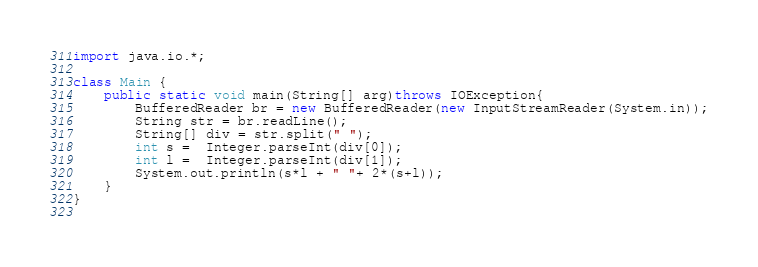<code> <loc_0><loc_0><loc_500><loc_500><_Java_>import java.io.*;

class Main {
    public static void main(String[] arg)throws IOException{
        BufferedReader br = new BufferedReader(new InputStreamReader(System.in));
        String str = br.readLine();
        String[] div = str.split(" ");
        int s =  Integer.parseInt(div[0]);
        int l =  Integer.parseInt(div[1]);
        System.out.println(s*l + " "+ 2*(s+l));
    }   
}
 </code> 